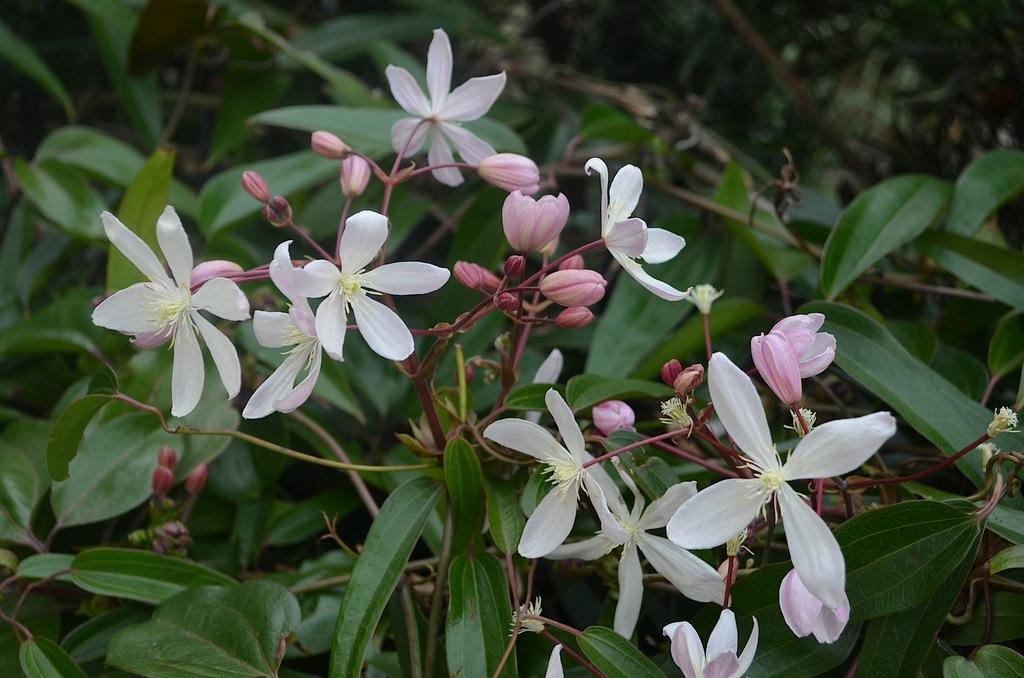What type of plants can be seen in the image? There are flower plants in the image. What color are the leaves of the plants? Green leaves are present in the image. What color are the flowers on the plants? White flowers are visible in the image. Are there any unopened flowers on the plants? Flower buds are in the image. What type of chalk is being used to draw on the flowers in the image? There is no chalk or drawing activity present in the image; it features flower plants with green leaves, white flowers, and flower buds. 